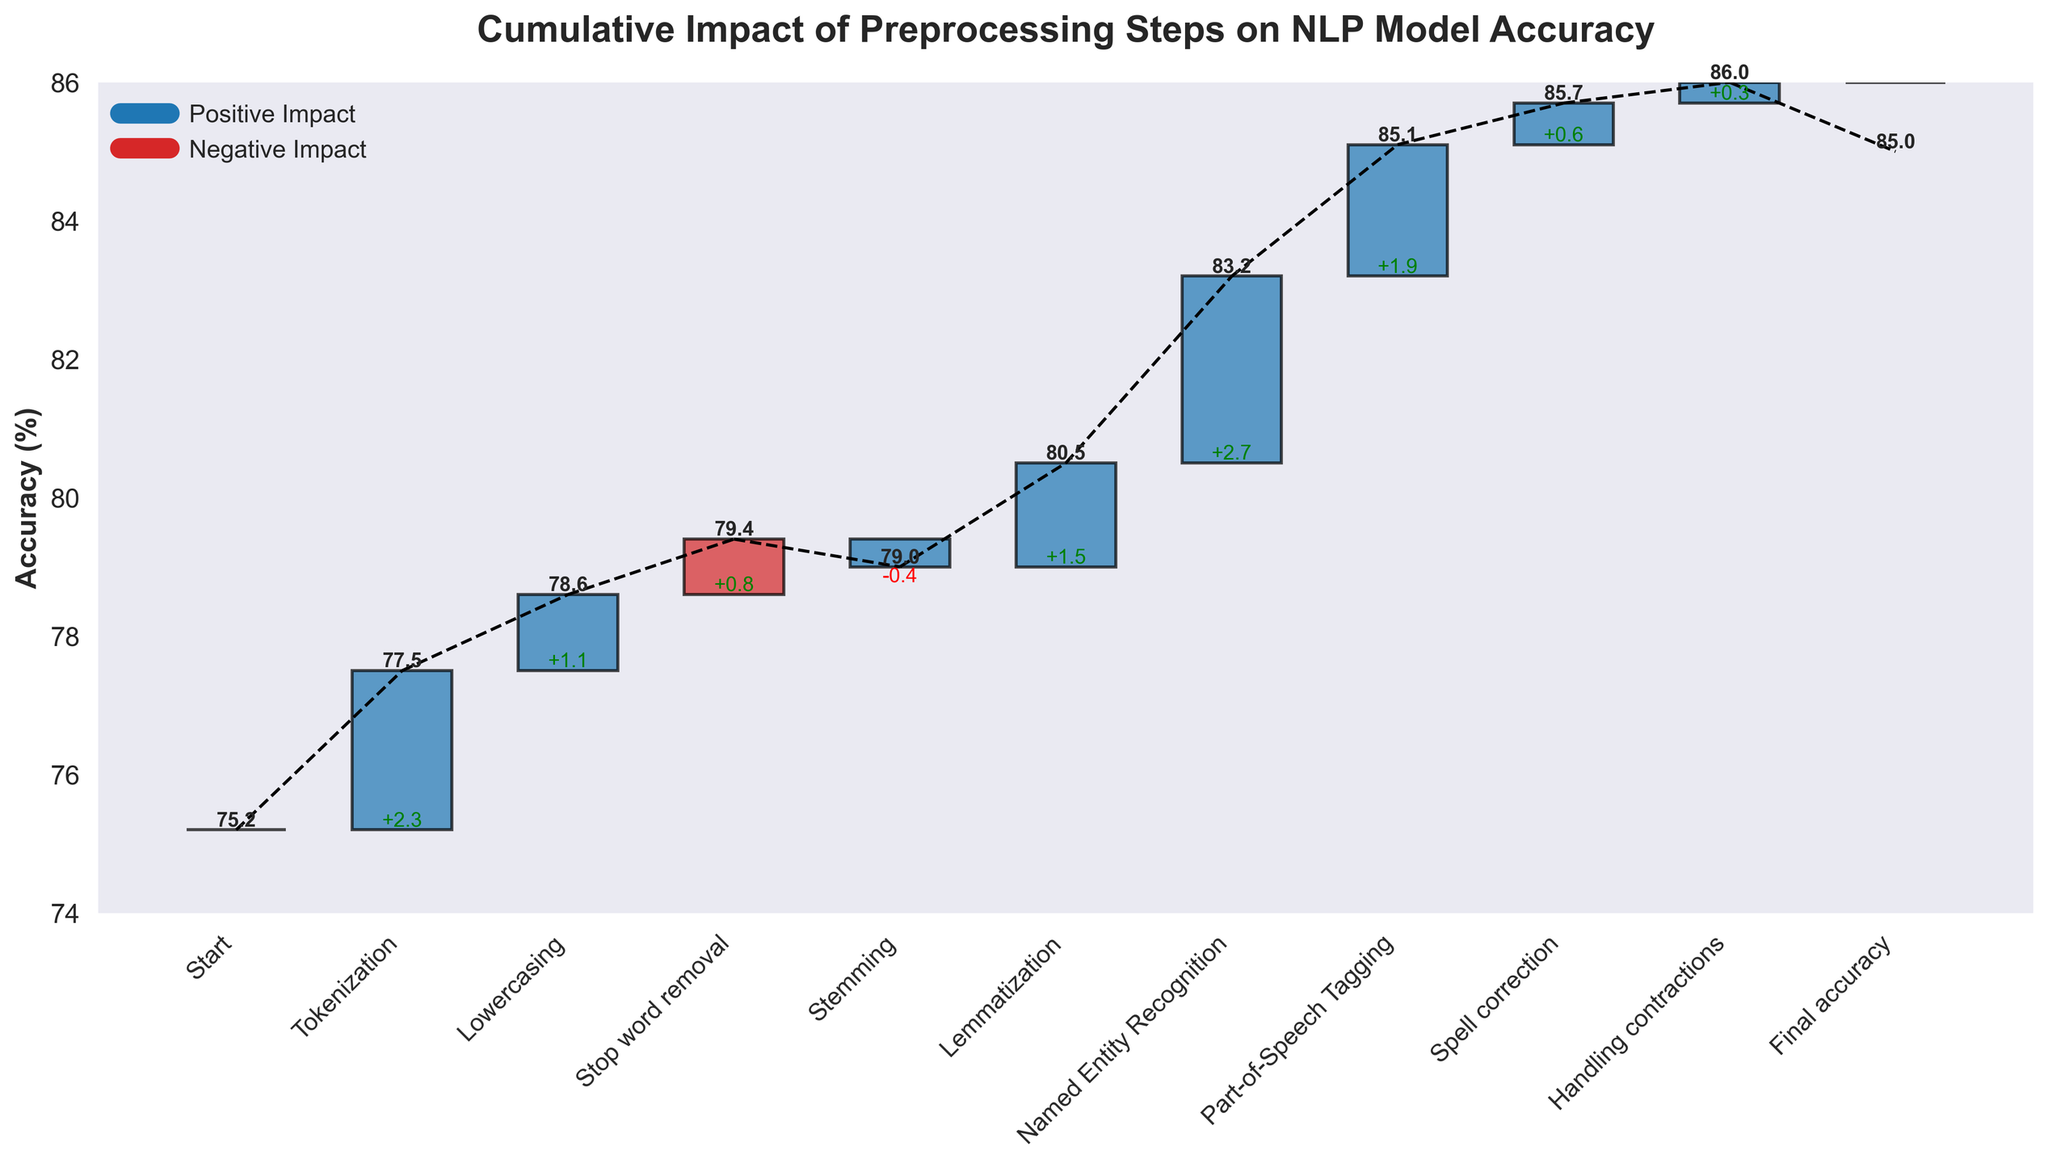what's the initial accuracy of the model before any preprocessing steps? The first bar in the plot refers to the "Start" point of the model's accuracy before any preprocessing, which is labeled as 75.2%.
Answer: 75.2% Which preprocessing step led to the largest improvement in model accuracy? By comparing the vertical distances of the bars, Named Entity Recognition has the highest positive impact with a value of +2.7%.
Answer: Named Entity Recognition What's the final accuracy of the model after all preprocessing steps? The last data point on the plot represents "Final accuracy," which is labeled as 85.0%.
Answer: 85.0% What's the combined impact of Tokenization and Lowercasing? Tokenization adds +2.3%, and Lowercasing adds +1.1%. Adding these together, the combined impact is 2.3% + 1.1% = 3.4%.
Answer: 3.4% Which preprocessing step had a negative impact on the model accuracy and by how much? Stemming had a negative impact as indicated by the downward bar, resulting in a value of -0.4%.
Answer: Stemming, -0.4% How many preprocessing steps contributed positively to the model's accuracy? Count the number of preprocessing steps with bars pointing upwards. Tokenization, Lowercasing, Stop word removal, Lemmatization, Named Entity Recognition, Part-of-Speech Tagging, and Spell correction contribute positively. This gives a total of 7 steps.
Answer: 7 What is the cumulative impact of Stop word removal, Stemming, and Lemmatization combined? Stop word removal adds +0.8%, Stemming subtracts -0.4%, and Lemmatization adds +1.5%. Summing these gives 0.8% - 0.4% + 1.5% = 1.9%.
Answer: 1.9% What's the accuracy change between the start point and after handling contractions? The initial accuracy is 75.2% and after handling contractions the cumulative total approximates 84.7%. Hence, the change is 84.7% - 75.2% = 9.5%.
Answer: 9.5% Which preprocessing step followed Named Entity Recognition, and what was its impact? Part-of-Speech Tagging follows Named Entity Recognition in the figure and its impact is +1.9%.
Answer: Part-of-Speech Tagging, +1.9% By how many percentage points did the accuracy improve from after Stemming to after Named Entity Recognition? After Stemming, the cumulative accuracy is around 77.4% (75.2% + 2.3% + 1.1% + 0.8% - 0.4%). Adding Lemmatization and Named Entity Recognition will bring us to 81.6 (77.4% + 1.5 + 2.7). Hence, the improvement is 81.6% - 77.4% = 4.2%.
Answer: 4.2% 